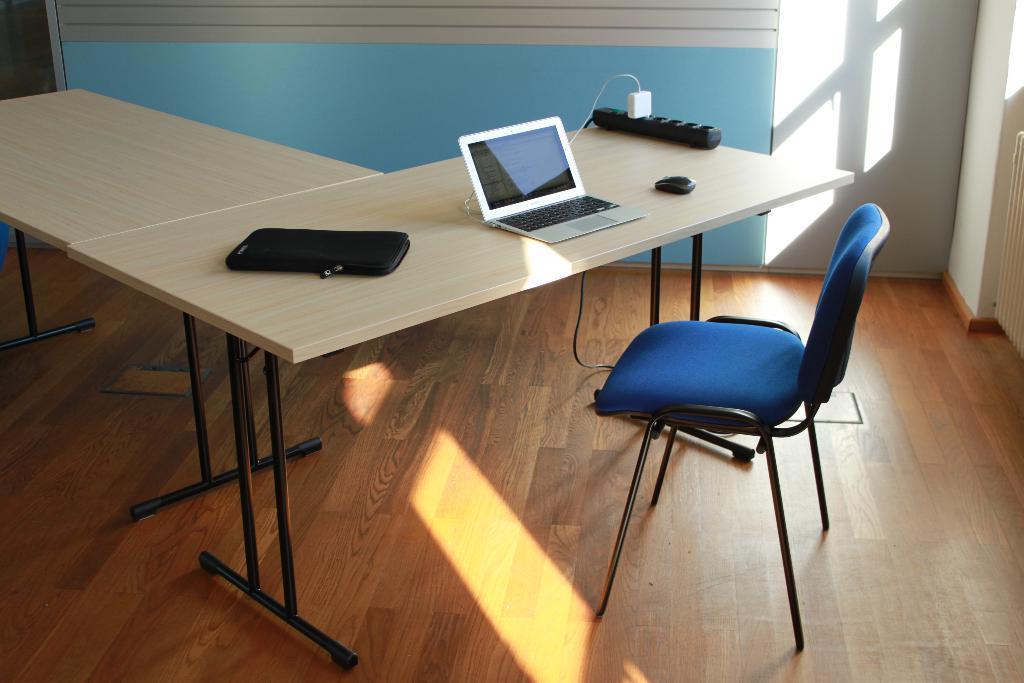Please provide a concise description of this image. In this image we can see a table an don the table there are cell phone, laptop, laptop cover, mouse, plug in the extension board, chair and walls. 